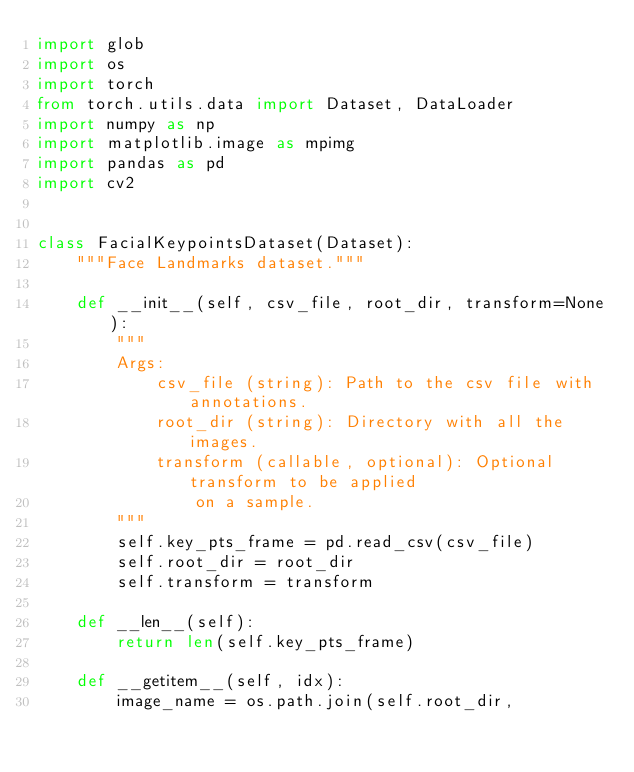<code> <loc_0><loc_0><loc_500><loc_500><_Python_>import glob
import os
import torch
from torch.utils.data import Dataset, DataLoader
import numpy as np
import matplotlib.image as mpimg
import pandas as pd
import cv2


class FacialKeypointsDataset(Dataset):
    """Face Landmarks dataset."""

    def __init__(self, csv_file, root_dir, transform=None):
        """
        Args:
            csv_file (string): Path to the csv file with annotations.
            root_dir (string): Directory with all the images.
            transform (callable, optional): Optional transform to be applied
                on a sample.
        """
        self.key_pts_frame = pd.read_csv(csv_file)
        self.root_dir = root_dir
        self.transform = transform

    def __len__(self):
        return len(self.key_pts_frame)

    def __getitem__(self, idx):
        image_name = os.path.join(self.root_dir,</code> 